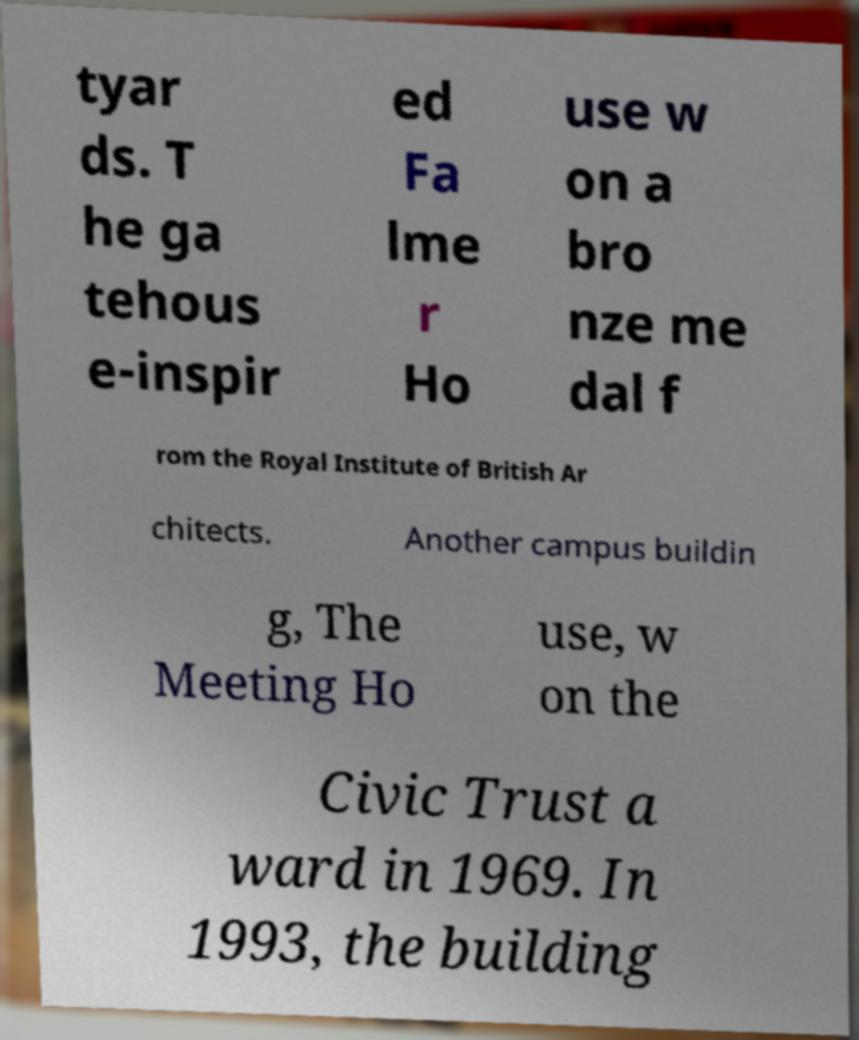Can you read and provide the text displayed in the image?This photo seems to have some interesting text. Can you extract and type it out for me? tyar ds. T he ga tehous e-inspir ed Fa lme r Ho use w on a bro nze me dal f rom the Royal Institute of British Ar chitects. Another campus buildin g, The Meeting Ho use, w on the Civic Trust a ward in 1969. In 1993, the building 